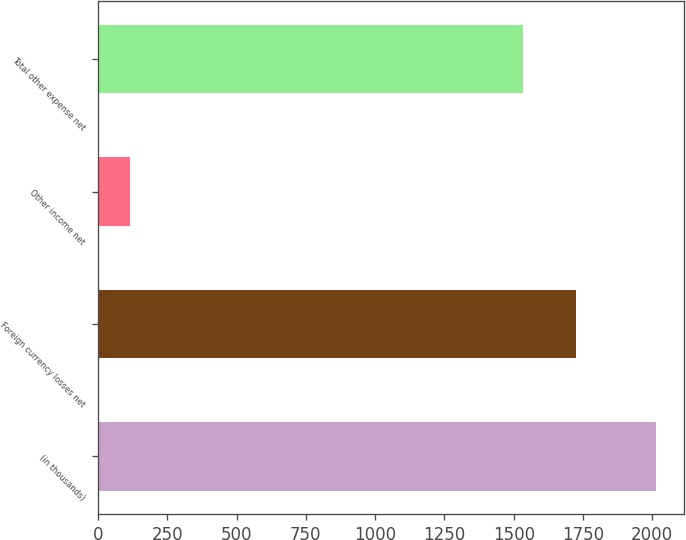Convert chart. <chart><loc_0><loc_0><loc_500><loc_500><bar_chart><fcel>(in thousands)<fcel>Foreign currency losses net<fcel>Other income net<fcel>Total other expense net<nl><fcel>2014<fcel>1723.9<fcel>115<fcel>1534<nl></chart> 